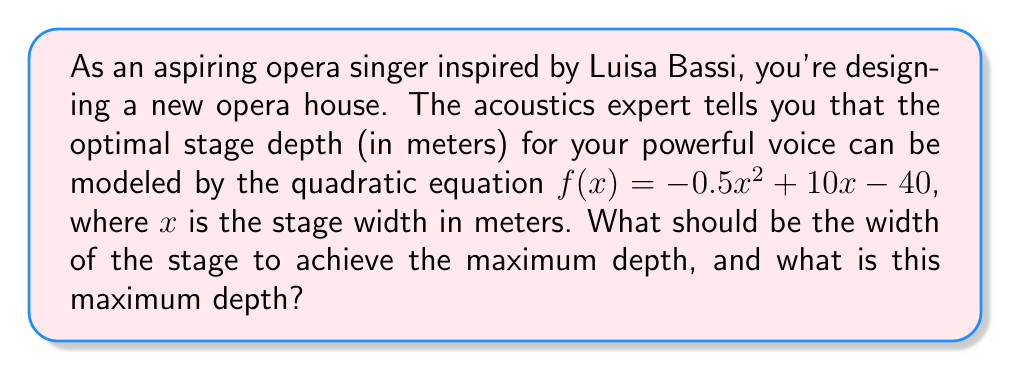Solve this math problem. To solve this problem, we'll follow these steps:

1) The given quadratic equation is in the form $f(x) = ax^2 + bx + c$, where:
   $a = -0.5$, $b = 10$, and $c = -40$

2) For a quadratic function, the x-coordinate of the vertex represents the value of x that gives the maximum y-value (in this case, the stage width that gives the maximum depth). We can find this using the formula:

   $x = -\frac{b}{2a}$

3) Substituting our values:

   $x = -\frac{10}{2(-0.5)} = -\frac{10}{-1} = 10$

4) So, the optimal width of the stage is 10 meters.

5) To find the maximum depth, we need to calculate $f(10)$:

   $f(10) = -0.5(10)^2 + 10(10) - 40$
   $= -0.5(100) + 100 - 40$
   $= -50 + 100 - 40$
   $= 10$

Therefore, the maximum depth of the stage is 10 meters.
Answer: The optimal stage width is 10 meters, which results in a maximum stage depth of 10 meters. 